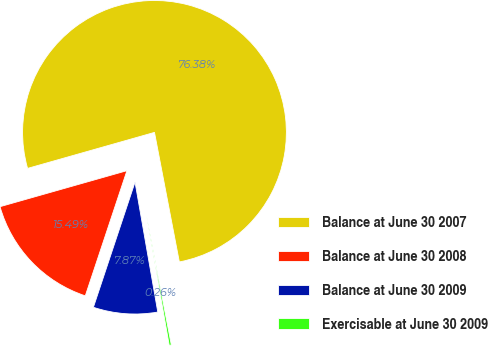Convert chart to OTSL. <chart><loc_0><loc_0><loc_500><loc_500><pie_chart><fcel>Balance at June 30 2007<fcel>Balance at June 30 2008<fcel>Balance at June 30 2009<fcel>Exercisable at June 30 2009<nl><fcel>76.38%<fcel>15.49%<fcel>7.87%<fcel>0.26%<nl></chart> 